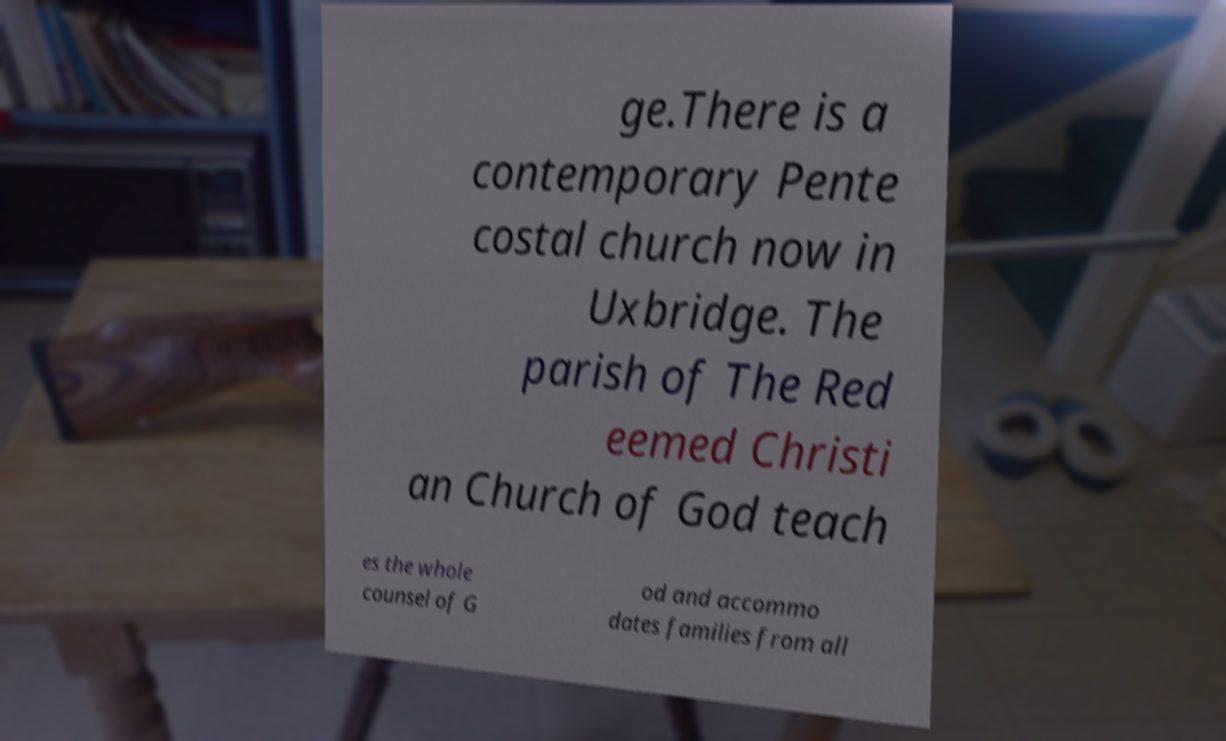Can you read and provide the text displayed in the image?This photo seems to have some interesting text. Can you extract and type it out for me? ge.There is a contemporary Pente costal church now in Uxbridge. The parish of The Red eemed Christi an Church of God teach es the whole counsel of G od and accommo dates families from all 